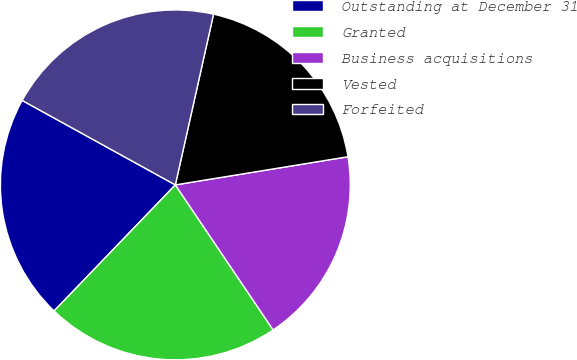<chart> <loc_0><loc_0><loc_500><loc_500><pie_chart><fcel>Outstanding at December 31<fcel>Granted<fcel>Business acquisitions<fcel>Vested<fcel>Forfeited<nl><fcel>20.83%<fcel>21.63%<fcel>18.13%<fcel>18.92%<fcel>20.48%<nl></chart> 